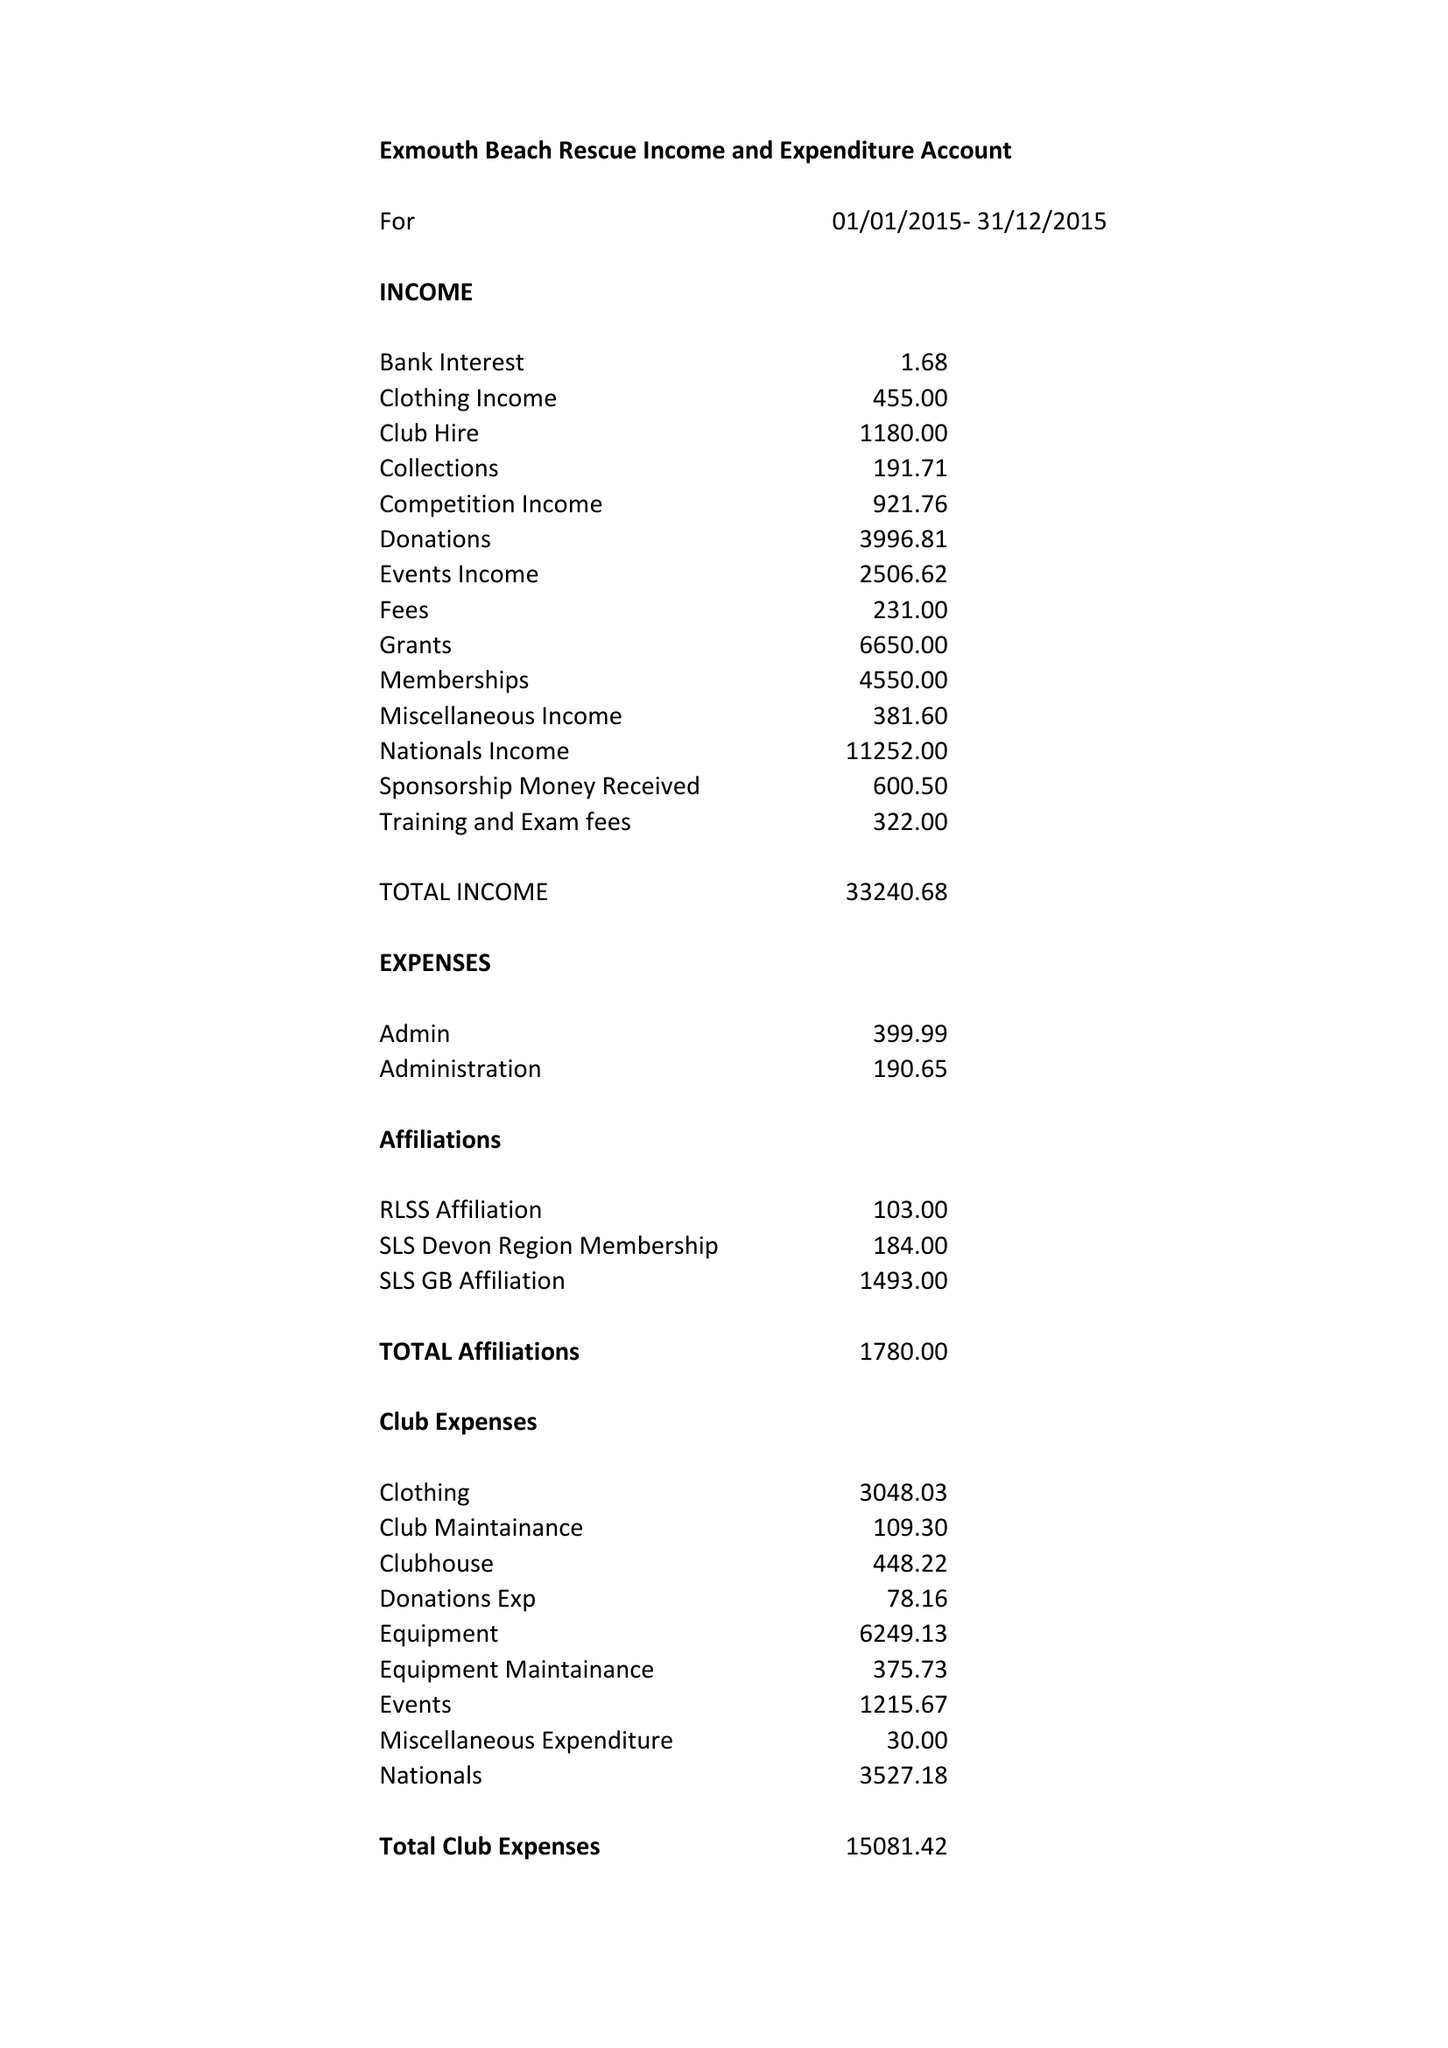What is the value for the report_date?
Answer the question using a single word or phrase. 2015-12-31 